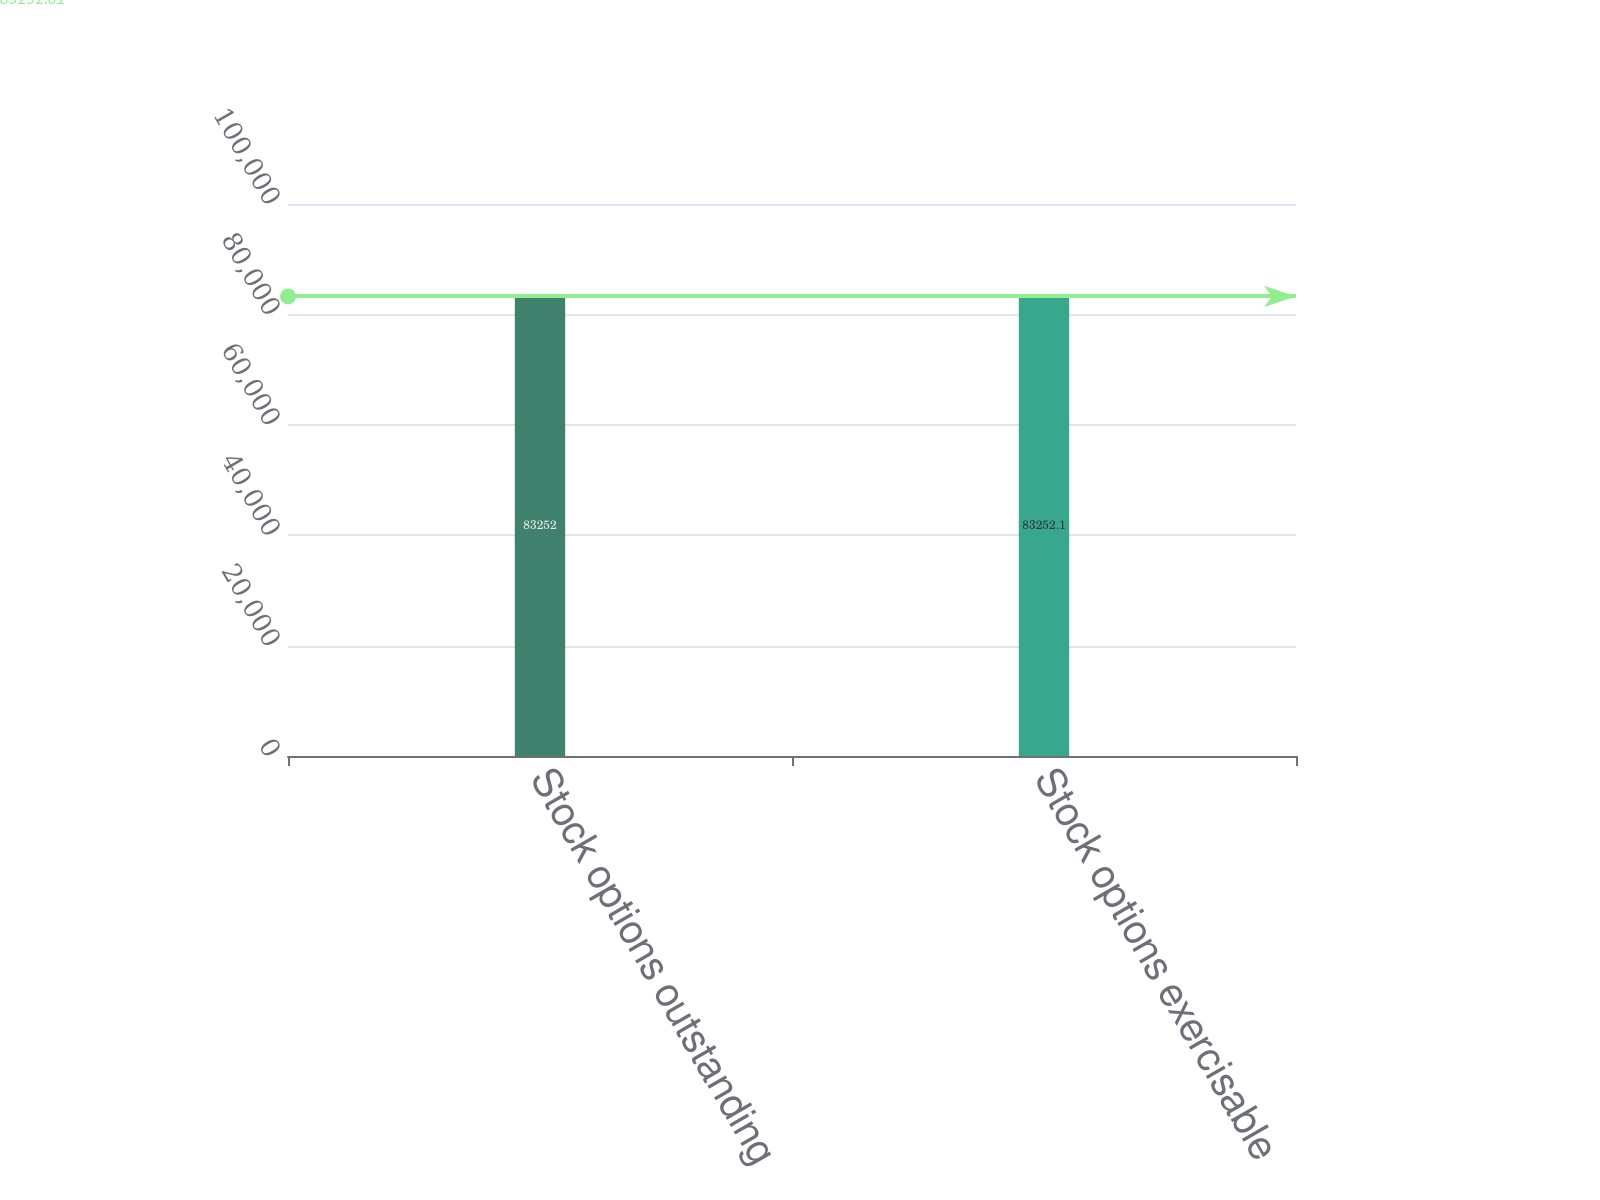Convert chart to OTSL. <chart><loc_0><loc_0><loc_500><loc_500><bar_chart><fcel>Stock options outstanding<fcel>Stock options exercisable<nl><fcel>83252<fcel>83252.1<nl></chart> 